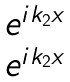<formula> <loc_0><loc_0><loc_500><loc_500>\begin{matrix} e ^ { i k _ { 2 } x } \\ e ^ { i k _ { 2 } x } \end{matrix}</formula> 